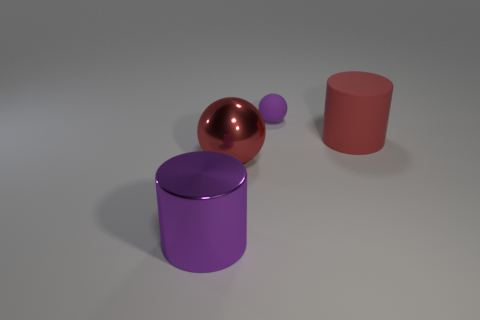Add 2 big cyan shiny spheres. How many objects exist? 6 Add 3 small rubber things. How many small rubber things are left? 4 Add 2 big red matte things. How many big red matte things exist? 3 Subtract 0 blue cylinders. How many objects are left? 4 Subtract all cylinders. Subtract all large red matte things. How many objects are left? 1 